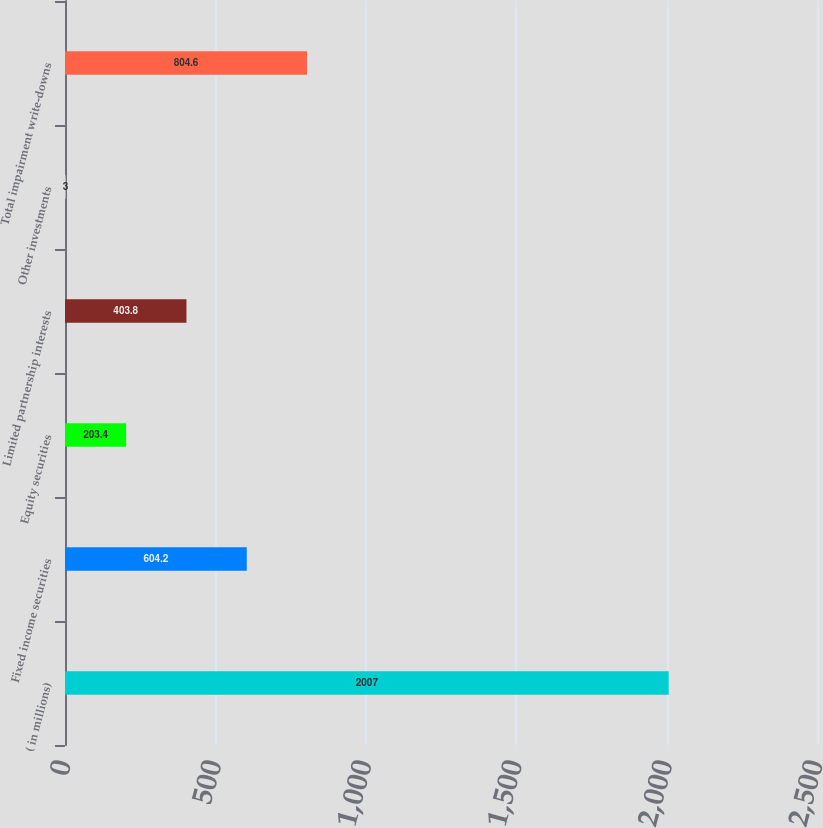Convert chart to OTSL. <chart><loc_0><loc_0><loc_500><loc_500><bar_chart><fcel>( in millions)<fcel>Fixed income securities<fcel>Equity securities<fcel>Limited partnership interests<fcel>Other investments<fcel>Total impairment write-downs<nl><fcel>2007<fcel>604.2<fcel>203.4<fcel>403.8<fcel>3<fcel>804.6<nl></chart> 